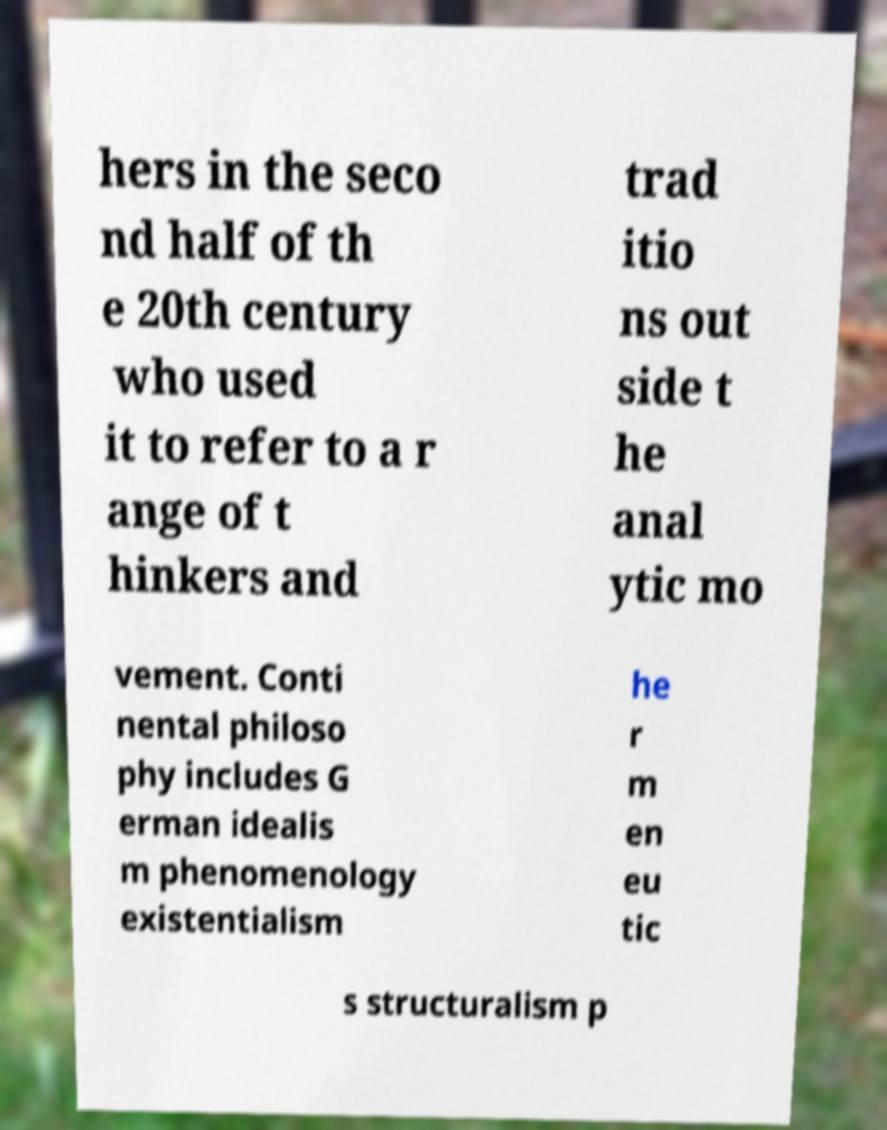Please identify and transcribe the text found in this image. hers in the seco nd half of th e 20th century who used it to refer to a r ange of t hinkers and trad itio ns out side t he anal ytic mo vement. Conti nental philoso phy includes G erman idealis m phenomenology existentialism he r m en eu tic s structuralism p 